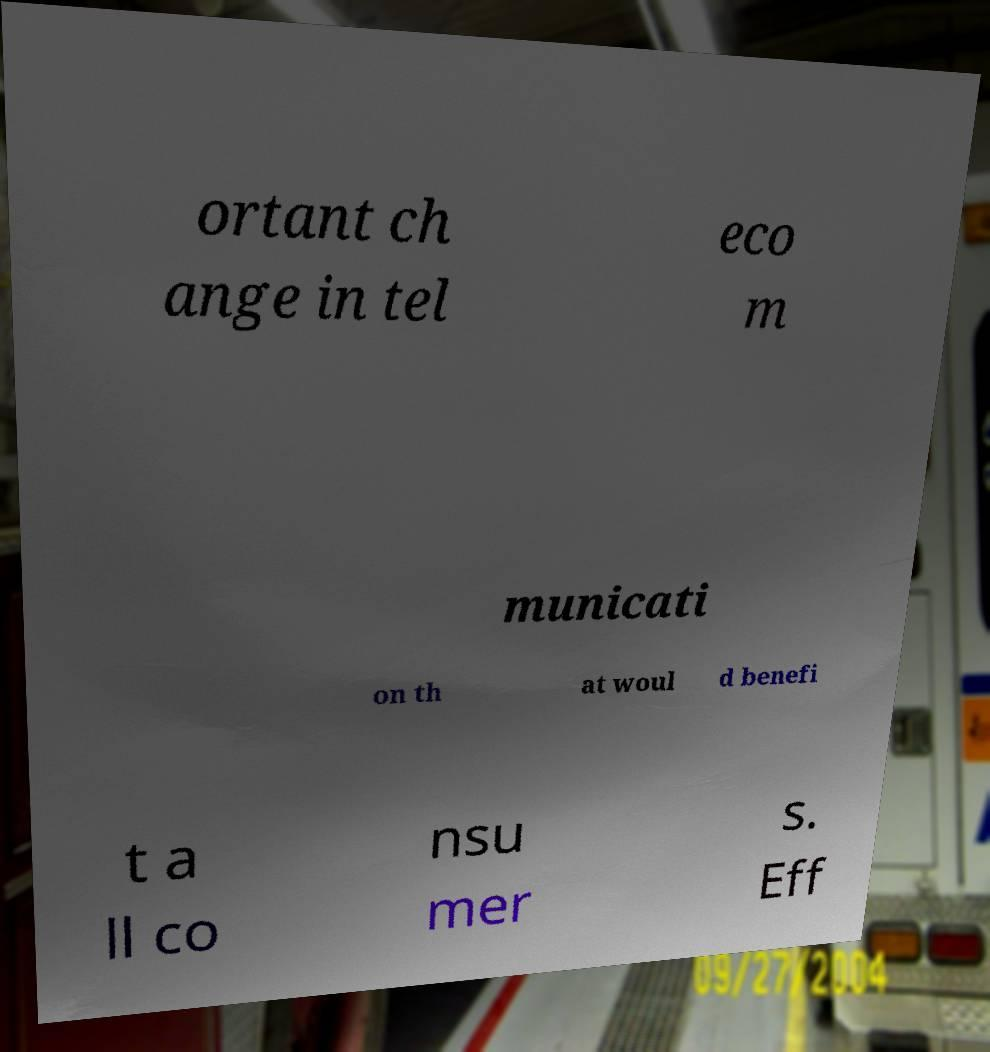For documentation purposes, I need the text within this image transcribed. Could you provide that? ortant ch ange in tel eco m municati on th at woul d benefi t a ll co nsu mer s. Eff 